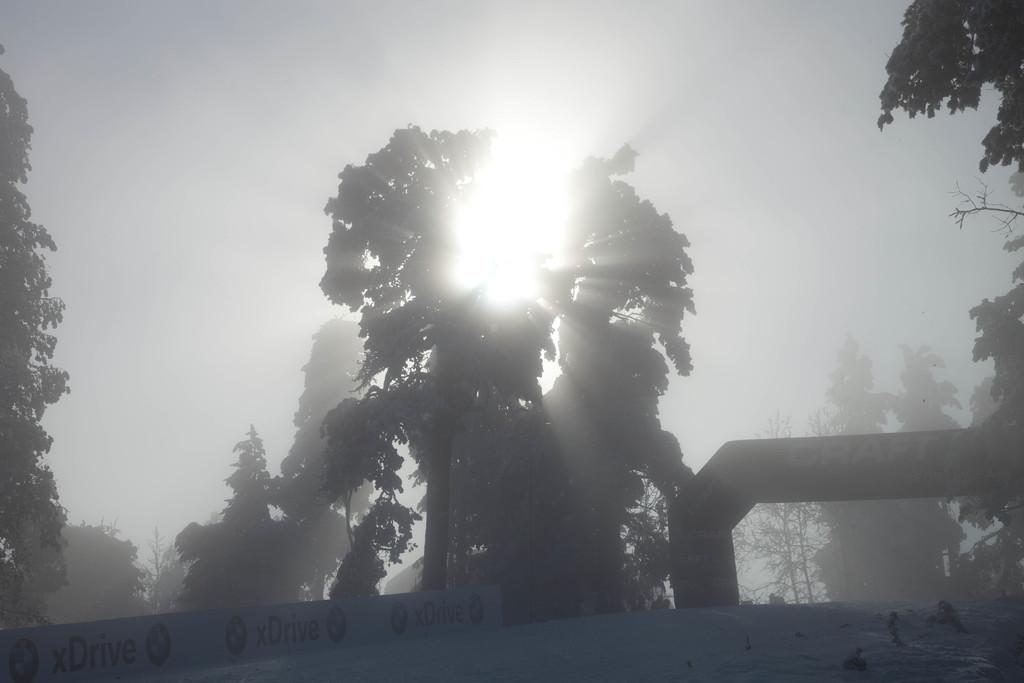What type of vegetation can be seen in the image? There are trees in the image. What type of coat is hanging on the tree in the image? There is no coat present in the image; it only features trees. How many buttons can be seen on the snakes in the image? There are no snakes or buttons present in the image; it only features trees. 